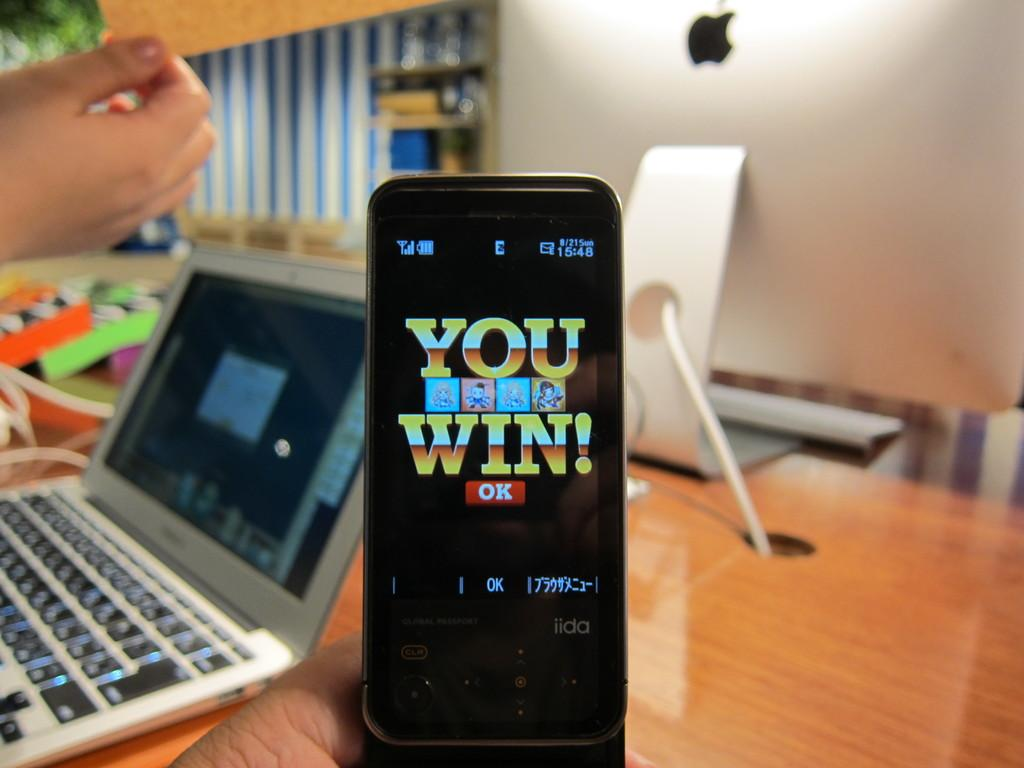<image>
Offer a succinct explanation of the picture presented. Phone screen that says You Win on it. 